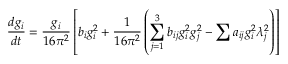<formula> <loc_0><loc_0><loc_500><loc_500>{ \frac { d g _ { i } } { d t } } = { \frac { g _ { i } } { 1 6 \pi ^ { 2 } } } \left [ b _ { i } g _ { i } ^ { 2 } + { \frac { 1 } { 1 6 \pi ^ { 2 } } } \left ( \sum _ { j = 1 } ^ { 3 } b _ { i j } g _ { i } ^ { 2 } g _ { j } ^ { 2 } - \sum a _ { i j } g _ { i } ^ { 2 } \lambda _ { j } ^ { 2 } \right ) \right ]</formula> 